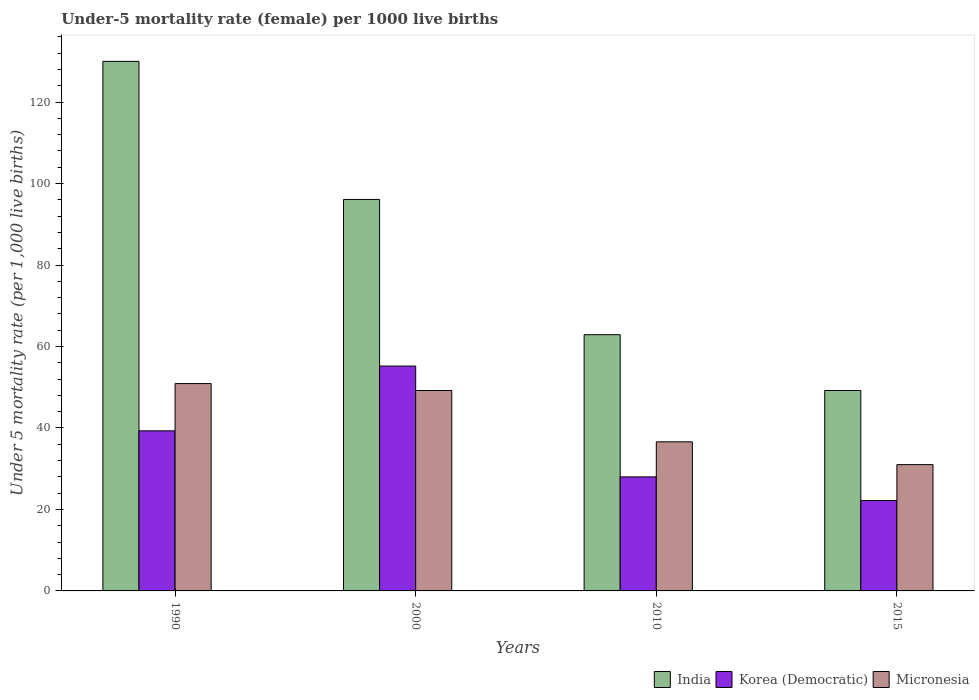How many different coloured bars are there?
Offer a terse response. 3. How many groups of bars are there?
Ensure brevity in your answer.  4. Are the number of bars on each tick of the X-axis equal?
Your answer should be compact. Yes. How many bars are there on the 1st tick from the left?
Provide a short and direct response. 3. What is the label of the 1st group of bars from the left?
Make the answer very short. 1990. What is the under-five mortality rate in India in 1990?
Provide a short and direct response. 130. Across all years, what is the maximum under-five mortality rate in Korea (Democratic)?
Your answer should be compact. 55.2. In which year was the under-five mortality rate in Korea (Democratic) maximum?
Offer a very short reply. 2000. In which year was the under-five mortality rate in Korea (Democratic) minimum?
Keep it short and to the point. 2015. What is the total under-five mortality rate in Korea (Democratic) in the graph?
Offer a terse response. 144.7. What is the difference between the under-five mortality rate in Korea (Democratic) in 2010 and that in 2015?
Your response must be concise. 5.8. What is the difference between the under-five mortality rate in Micronesia in 2010 and the under-five mortality rate in India in 2015?
Offer a very short reply. -12.6. What is the average under-five mortality rate in India per year?
Offer a terse response. 84.55. In the year 2000, what is the difference between the under-five mortality rate in India and under-five mortality rate in Korea (Democratic)?
Make the answer very short. 40.9. In how many years, is the under-five mortality rate in India greater than 8?
Your response must be concise. 4. What is the ratio of the under-five mortality rate in Micronesia in 2000 to that in 2015?
Offer a terse response. 1.59. Is the under-five mortality rate in Korea (Democratic) in 1990 less than that in 2015?
Ensure brevity in your answer.  No. Is the difference between the under-five mortality rate in India in 2000 and 2010 greater than the difference between the under-five mortality rate in Korea (Democratic) in 2000 and 2010?
Make the answer very short. Yes. What is the difference between the highest and the second highest under-five mortality rate in Micronesia?
Your answer should be compact. 1.7. What is the difference between the highest and the lowest under-five mortality rate in Korea (Democratic)?
Your answer should be compact. 33. In how many years, is the under-five mortality rate in Micronesia greater than the average under-five mortality rate in Micronesia taken over all years?
Your response must be concise. 2. Is the sum of the under-five mortality rate in India in 2010 and 2015 greater than the maximum under-five mortality rate in Micronesia across all years?
Offer a terse response. Yes. What does the 2nd bar from the left in 1990 represents?
Your response must be concise. Korea (Democratic). What does the 2nd bar from the right in 2000 represents?
Your response must be concise. Korea (Democratic). Is it the case that in every year, the sum of the under-five mortality rate in Korea (Democratic) and under-five mortality rate in Micronesia is greater than the under-five mortality rate in India?
Provide a short and direct response. No. Are all the bars in the graph horizontal?
Provide a short and direct response. No. Does the graph contain any zero values?
Offer a very short reply. No. How many legend labels are there?
Ensure brevity in your answer.  3. What is the title of the graph?
Keep it short and to the point. Under-5 mortality rate (female) per 1000 live births. Does "Moldova" appear as one of the legend labels in the graph?
Your response must be concise. No. What is the label or title of the Y-axis?
Offer a terse response. Under 5 mortality rate (per 1,0 live births). What is the Under 5 mortality rate (per 1,000 live births) in India in 1990?
Provide a succinct answer. 130. What is the Under 5 mortality rate (per 1,000 live births) of Korea (Democratic) in 1990?
Provide a short and direct response. 39.3. What is the Under 5 mortality rate (per 1,000 live births) in Micronesia in 1990?
Keep it short and to the point. 50.9. What is the Under 5 mortality rate (per 1,000 live births) in India in 2000?
Your answer should be compact. 96.1. What is the Under 5 mortality rate (per 1,000 live births) in Korea (Democratic) in 2000?
Provide a succinct answer. 55.2. What is the Under 5 mortality rate (per 1,000 live births) in Micronesia in 2000?
Keep it short and to the point. 49.2. What is the Under 5 mortality rate (per 1,000 live births) in India in 2010?
Your answer should be compact. 62.9. What is the Under 5 mortality rate (per 1,000 live births) of Micronesia in 2010?
Your response must be concise. 36.6. What is the Under 5 mortality rate (per 1,000 live births) of India in 2015?
Provide a short and direct response. 49.2. What is the Under 5 mortality rate (per 1,000 live births) of Korea (Democratic) in 2015?
Your response must be concise. 22.2. What is the Under 5 mortality rate (per 1,000 live births) of Micronesia in 2015?
Make the answer very short. 31. Across all years, what is the maximum Under 5 mortality rate (per 1,000 live births) in India?
Offer a very short reply. 130. Across all years, what is the maximum Under 5 mortality rate (per 1,000 live births) in Korea (Democratic)?
Keep it short and to the point. 55.2. Across all years, what is the maximum Under 5 mortality rate (per 1,000 live births) in Micronesia?
Ensure brevity in your answer.  50.9. Across all years, what is the minimum Under 5 mortality rate (per 1,000 live births) in India?
Your response must be concise. 49.2. Across all years, what is the minimum Under 5 mortality rate (per 1,000 live births) of Korea (Democratic)?
Keep it short and to the point. 22.2. Across all years, what is the minimum Under 5 mortality rate (per 1,000 live births) of Micronesia?
Provide a short and direct response. 31. What is the total Under 5 mortality rate (per 1,000 live births) of India in the graph?
Keep it short and to the point. 338.2. What is the total Under 5 mortality rate (per 1,000 live births) of Korea (Democratic) in the graph?
Your answer should be very brief. 144.7. What is the total Under 5 mortality rate (per 1,000 live births) of Micronesia in the graph?
Provide a succinct answer. 167.7. What is the difference between the Under 5 mortality rate (per 1,000 live births) of India in 1990 and that in 2000?
Provide a succinct answer. 33.9. What is the difference between the Under 5 mortality rate (per 1,000 live births) in Korea (Democratic) in 1990 and that in 2000?
Your answer should be very brief. -15.9. What is the difference between the Under 5 mortality rate (per 1,000 live births) in Micronesia in 1990 and that in 2000?
Keep it short and to the point. 1.7. What is the difference between the Under 5 mortality rate (per 1,000 live births) of India in 1990 and that in 2010?
Make the answer very short. 67.1. What is the difference between the Under 5 mortality rate (per 1,000 live births) of Korea (Democratic) in 1990 and that in 2010?
Keep it short and to the point. 11.3. What is the difference between the Under 5 mortality rate (per 1,000 live births) in Micronesia in 1990 and that in 2010?
Provide a short and direct response. 14.3. What is the difference between the Under 5 mortality rate (per 1,000 live births) in India in 1990 and that in 2015?
Your answer should be very brief. 80.8. What is the difference between the Under 5 mortality rate (per 1,000 live births) of Korea (Democratic) in 1990 and that in 2015?
Provide a short and direct response. 17.1. What is the difference between the Under 5 mortality rate (per 1,000 live births) of Micronesia in 1990 and that in 2015?
Keep it short and to the point. 19.9. What is the difference between the Under 5 mortality rate (per 1,000 live births) in India in 2000 and that in 2010?
Offer a terse response. 33.2. What is the difference between the Under 5 mortality rate (per 1,000 live births) of Korea (Democratic) in 2000 and that in 2010?
Offer a terse response. 27.2. What is the difference between the Under 5 mortality rate (per 1,000 live births) in Micronesia in 2000 and that in 2010?
Give a very brief answer. 12.6. What is the difference between the Under 5 mortality rate (per 1,000 live births) of India in 2000 and that in 2015?
Your answer should be compact. 46.9. What is the difference between the Under 5 mortality rate (per 1,000 live births) in India in 2010 and that in 2015?
Your response must be concise. 13.7. What is the difference between the Under 5 mortality rate (per 1,000 live births) of India in 1990 and the Under 5 mortality rate (per 1,000 live births) of Korea (Democratic) in 2000?
Make the answer very short. 74.8. What is the difference between the Under 5 mortality rate (per 1,000 live births) in India in 1990 and the Under 5 mortality rate (per 1,000 live births) in Micronesia in 2000?
Make the answer very short. 80.8. What is the difference between the Under 5 mortality rate (per 1,000 live births) in India in 1990 and the Under 5 mortality rate (per 1,000 live births) in Korea (Democratic) in 2010?
Your answer should be very brief. 102. What is the difference between the Under 5 mortality rate (per 1,000 live births) of India in 1990 and the Under 5 mortality rate (per 1,000 live births) of Micronesia in 2010?
Give a very brief answer. 93.4. What is the difference between the Under 5 mortality rate (per 1,000 live births) of Korea (Democratic) in 1990 and the Under 5 mortality rate (per 1,000 live births) of Micronesia in 2010?
Your response must be concise. 2.7. What is the difference between the Under 5 mortality rate (per 1,000 live births) in India in 1990 and the Under 5 mortality rate (per 1,000 live births) in Korea (Democratic) in 2015?
Provide a succinct answer. 107.8. What is the difference between the Under 5 mortality rate (per 1,000 live births) in India in 1990 and the Under 5 mortality rate (per 1,000 live births) in Micronesia in 2015?
Provide a succinct answer. 99. What is the difference between the Under 5 mortality rate (per 1,000 live births) in India in 2000 and the Under 5 mortality rate (per 1,000 live births) in Korea (Democratic) in 2010?
Provide a succinct answer. 68.1. What is the difference between the Under 5 mortality rate (per 1,000 live births) in India in 2000 and the Under 5 mortality rate (per 1,000 live births) in Micronesia in 2010?
Your answer should be very brief. 59.5. What is the difference between the Under 5 mortality rate (per 1,000 live births) of Korea (Democratic) in 2000 and the Under 5 mortality rate (per 1,000 live births) of Micronesia in 2010?
Your response must be concise. 18.6. What is the difference between the Under 5 mortality rate (per 1,000 live births) of India in 2000 and the Under 5 mortality rate (per 1,000 live births) of Korea (Democratic) in 2015?
Your answer should be compact. 73.9. What is the difference between the Under 5 mortality rate (per 1,000 live births) of India in 2000 and the Under 5 mortality rate (per 1,000 live births) of Micronesia in 2015?
Offer a very short reply. 65.1. What is the difference between the Under 5 mortality rate (per 1,000 live births) of Korea (Democratic) in 2000 and the Under 5 mortality rate (per 1,000 live births) of Micronesia in 2015?
Make the answer very short. 24.2. What is the difference between the Under 5 mortality rate (per 1,000 live births) in India in 2010 and the Under 5 mortality rate (per 1,000 live births) in Korea (Democratic) in 2015?
Ensure brevity in your answer.  40.7. What is the difference between the Under 5 mortality rate (per 1,000 live births) of India in 2010 and the Under 5 mortality rate (per 1,000 live births) of Micronesia in 2015?
Make the answer very short. 31.9. What is the difference between the Under 5 mortality rate (per 1,000 live births) of Korea (Democratic) in 2010 and the Under 5 mortality rate (per 1,000 live births) of Micronesia in 2015?
Ensure brevity in your answer.  -3. What is the average Under 5 mortality rate (per 1,000 live births) of India per year?
Your response must be concise. 84.55. What is the average Under 5 mortality rate (per 1,000 live births) in Korea (Democratic) per year?
Give a very brief answer. 36.17. What is the average Under 5 mortality rate (per 1,000 live births) in Micronesia per year?
Ensure brevity in your answer.  41.92. In the year 1990, what is the difference between the Under 5 mortality rate (per 1,000 live births) in India and Under 5 mortality rate (per 1,000 live births) in Korea (Democratic)?
Your response must be concise. 90.7. In the year 1990, what is the difference between the Under 5 mortality rate (per 1,000 live births) in India and Under 5 mortality rate (per 1,000 live births) in Micronesia?
Offer a terse response. 79.1. In the year 2000, what is the difference between the Under 5 mortality rate (per 1,000 live births) of India and Under 5 mortality rate (per 1,000 live births) of Korea (Democratic)?
Provide a succinct answer. 40.9. In the year 2000, what is the difference between the Under 5 mortality rate (per 1,000 live births) of India and Under 5 mortality rate (per 1,000 live births) of Micronesia?
Offer a terse response. 46.9. In the year 2000, what is the difference between the Under 5 mortality rate (per 1,000 live births) in Korea (Democratic) and Under 5 mortality rate (per 1,000 live births) in Micronesia?
Ensure brevity in your answer.  6. In the year 2010, what is the difference between the Under 5 mortality rate (per 1,000 live births) of India and Under 5 mortality rate (per 1,000 live births) of Korea (Democratic)?
Offer a terse response. 34.9. In the year 2010, what is the difference between the Under 5 mortality rate (per 1,000 live births) of India and Under 5 mortality rate (per 1,000 live births) of Micronesia?
Your answer should be very brief. 26.3. In the year 2010, what is the difference between the Under 5 mortality rate (per 1,000 live births) of Korea (Democratic) and Under 5 mortality rate (per 1,000 live births) of Micronesia?
Your answer should be very brief. -8.6. In the year 2015, what is the difference between the Under 5 mortality rate (per 1,000 live births) in India and Under 5 mortality rate (per 1,000 live births) in Korea (Democratic)?
Give a very brief answer. 27. In the year 2015, what is the difference between the Under 5 mortality rate (per 1,000 live births) in India and Under 5 mortality rate (per 1,000 live births) in Micronesia?
Make the answer very short. 18.2. What is the ratio of the Under 5 mortality rate (per 1,000 live births) of India in 1990 to that in 2000?
Keep it short and to the point. 1.35. What is the ratio of the Under 5 mortality rate (per 1,000 live births) of Korea (Democratic) in 1990 to that in 2000?
Offer a terse response. 0.71. What is the ratio of the Under 5 mortality rate (per 1,000 live births) in Micronesia in 1990 to that in 2000?
Provide a succinct answer. 1.03. What is the ratio of the Under 5 mortality rate (per 1,000 live births) of India in 1990 to that in 2010?
Provide a short and direct response. 2.07. What is the ratio of the Under 5 mortality rate (per 1,000 live births) in Korea (Democratic) in 1990 to that in 2010?
Offer a very short reply. 1.4. What is the ratio of the Under 5 mortality rate (per 1,000 live births) of Micronesia in 1990 to that in 2010?
Provide a succinct answer. 1.39. What is the ratio of the Under 5 mortality rate (per 1,000 live births) of India in 1990 to that in 2015?
Offer a terse response. 2.64. What is the ratio of the Under 5 mortality rate (per 1,000 live births) of Korea (Democratic) in 1990 to that in 2015?
Provide a succinct answer. 1.77. What is the ratio of the Under 5 mortality rate (per 1,000 live births) in Micronesia in 1990 to that in 2015?
Offer a terse response. 1.64. What is the ratio of the Under 5 mortality rate (per 1,000 live births) of India in 2000 to that in 2010?
Make the answer very short. 1.53. What is the ratio of the Under 5 mortality rate (per 1,000 live births) in Korea (Democratic) in 2000 to that in 2010?
Give a very brief answer. 1.97. What is the ratio of the Under 5 mortality rate (per 1,000 live births) of Micronesia in 2000 to that in 2010?
Give a very brief answer. 1.34. What is the ratio of the Under 5 mortality rate (per 1,000 live births) in India in 2000 to that in 2015?
Ensure brevity in your answer.  1.95. What is the ratio of the Under 5 mortality rate (per 1,000 live births) of Korea (Democratic) in 2000 to that in 2015?
Your response must be concise. 2.49. What is the ratio of the Under 5 mortality rate (per 1,000 live births) in Micronesia in 2000 to that in 2015?
Give a very brief answer. 1.59. What is the ratio of the Under 5 mortality rate (per 1,000 live births) in India in 2010 to that in 2015?
Offer a terse response. 1.28. What is the ratio of the Under 5 mortality rate (per 1,000 live births) in Korea (Democratic) in 2010 to that in 2015?
Give a very brief answer. 1.26. What is the ratio of the Under 5 mortality rate (per 1,000 live births) in Micronesia in 2010 to that in 2015?
Provide a succinct answer. 1.18. What is the difference between the highest and the second highest Under 5 mortality rate (per 1,000 live births) of India?
Keep it short and to the point. 33.9. What is the difference between the highest and the lowest Under 5 mortality rate (per 1,000 live births) of India?
Ensure brevity in your answer.  80.8. What is the difference between the highest and the lowest Under 5 mortality rate (per 1,000 live births) of Micronesia?
Provide a succinct answer. 19.9. 